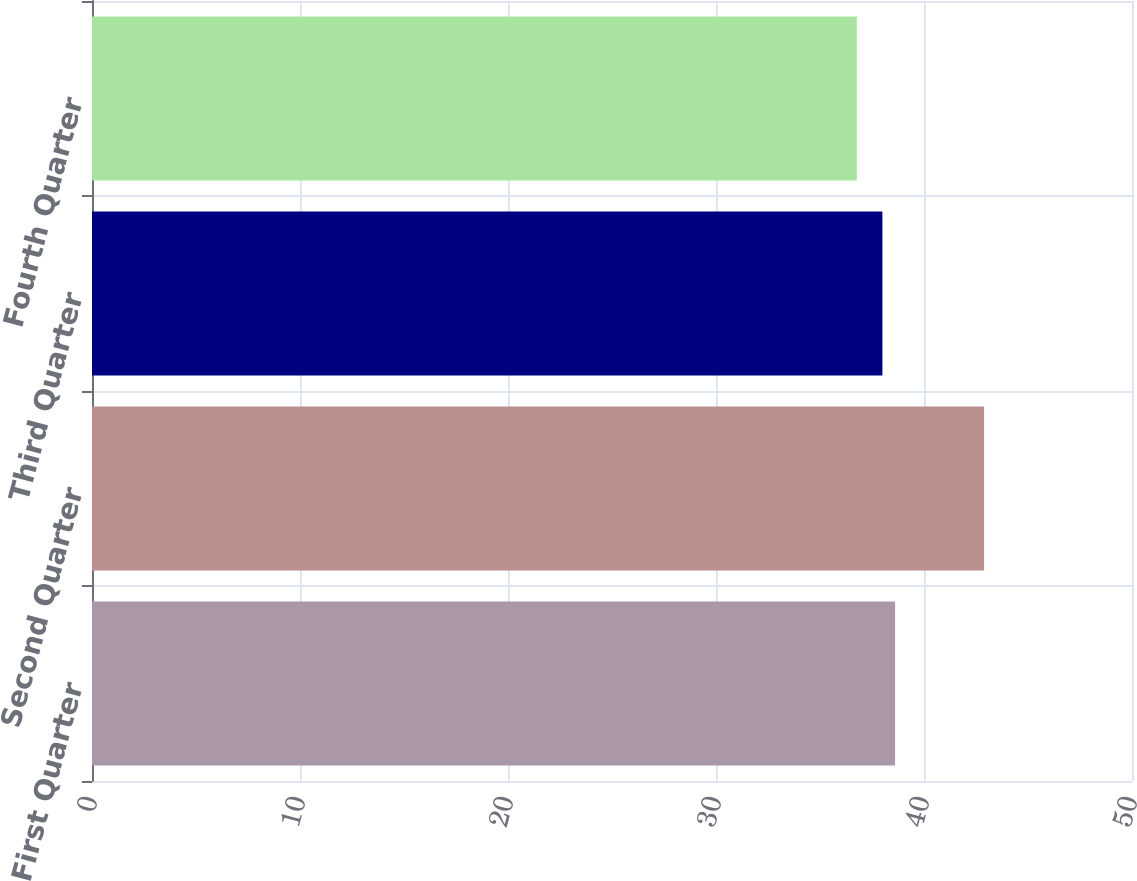<chart> <loc_0><loc_0><loc_500><loc_500><bar_chart><fcel>First Quarter<fcel>Second Quarter<fcel>Third Quarter<fcel>Fourth Quarter<nl><fcel>38.61<fcel>42.89<fcel>38<fcel>36.77<nl></chart> 